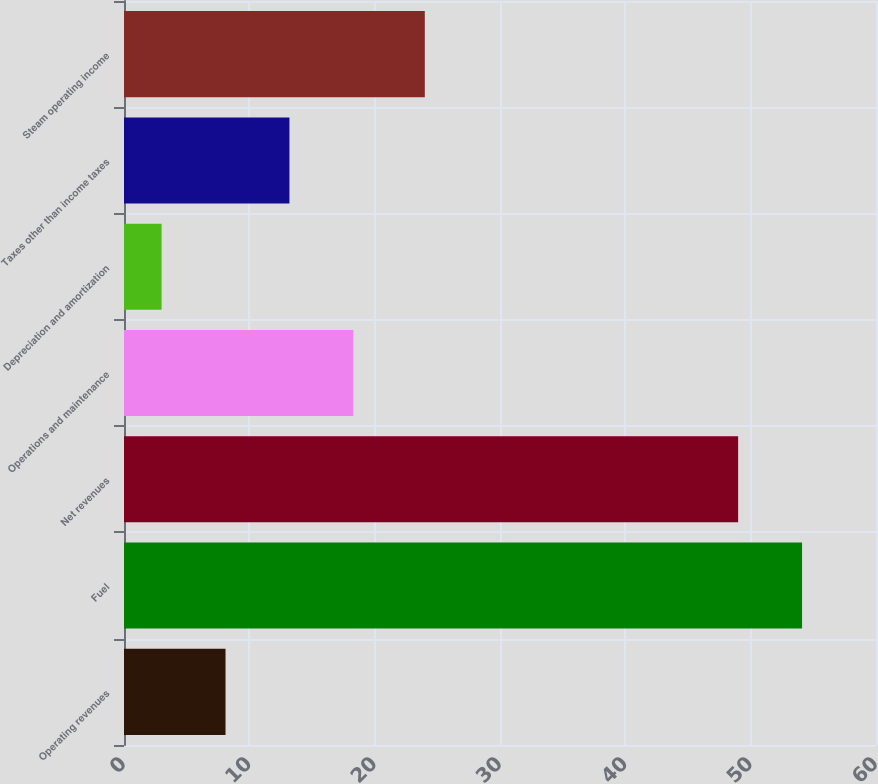<chart> <loc_0><loc_0><loc_500><loc_500><bar_chart><fcel>Operating revenues<fcel>Fuel<fcel>Net revenues<fcel>Operations and maintenance<fcel>Depreciation and amortization<fcel>Taxes other than income taxes<fcel>Steam operating income<nl><fcel>8.1<fcel>54.1<fcel>49<fcel>18.3<fcel>3<fcel>13.2<fcel>24<nl></chart> 